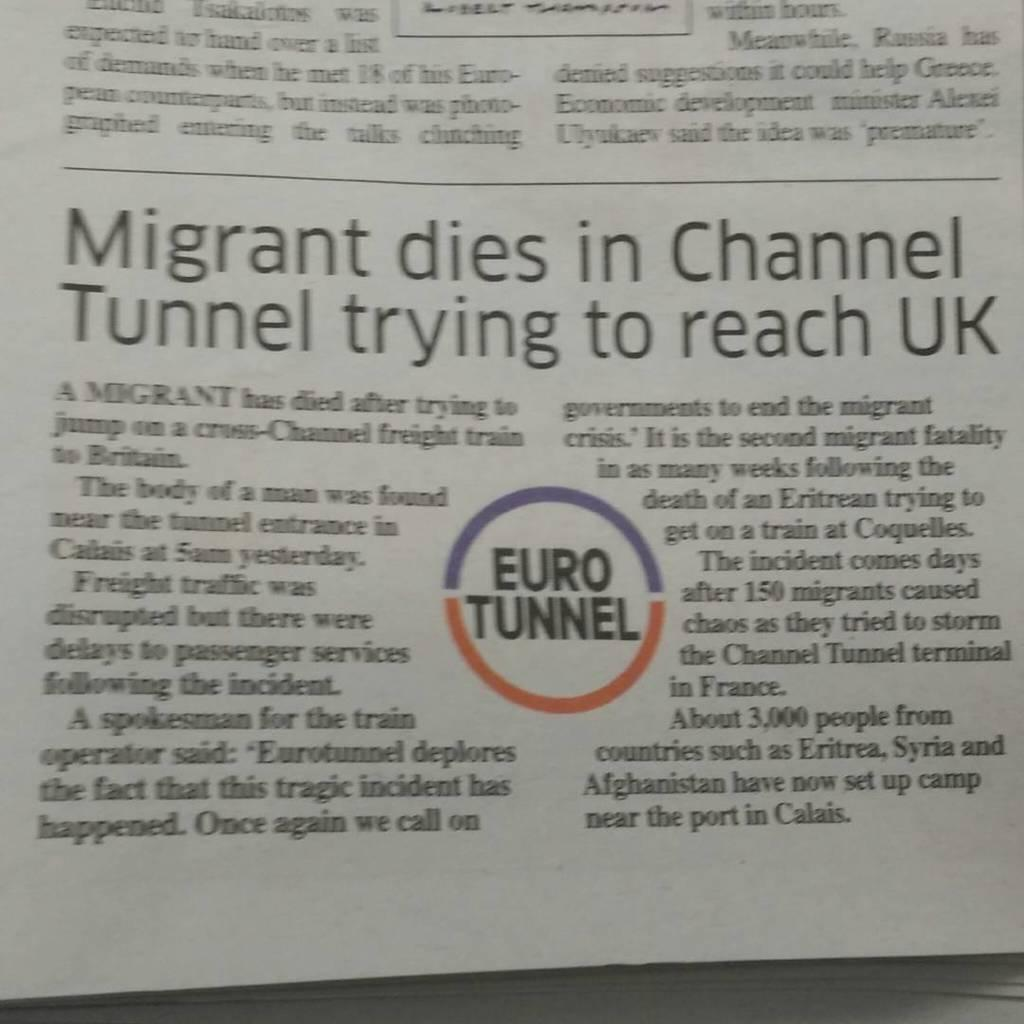<image>
Present a compact description of the photo's key features. A photo of a British newspaper story about a migrant dying in the Channel Tunnel. 